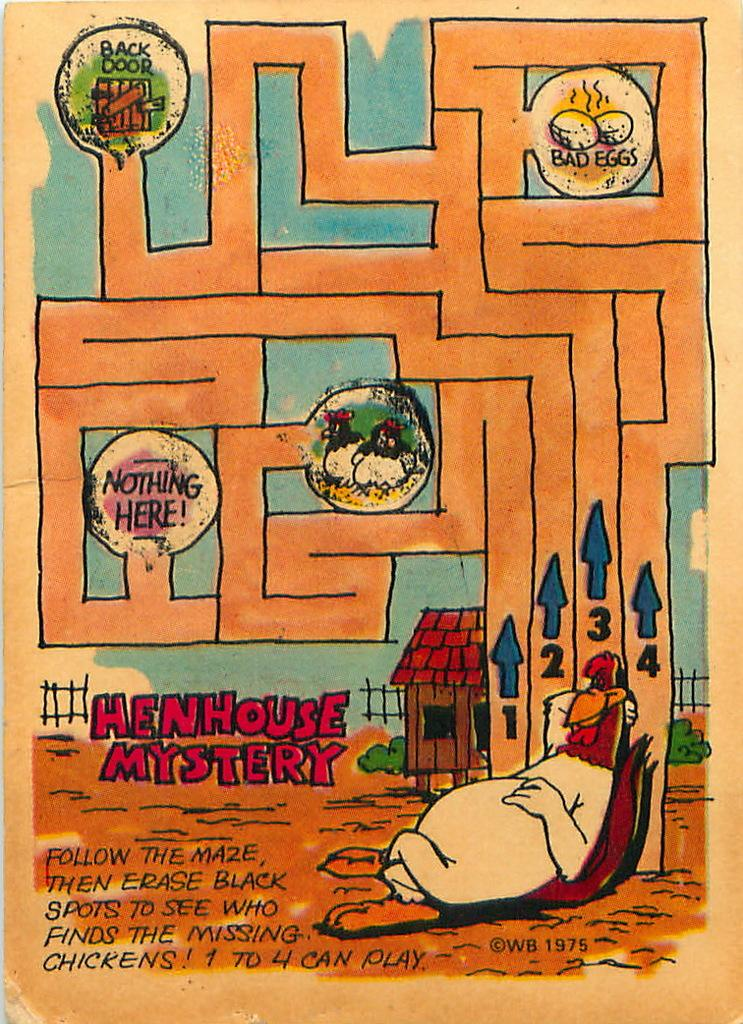<image>
Describe the image concisely. A maze is laid out for the Henhouse Mystery. 